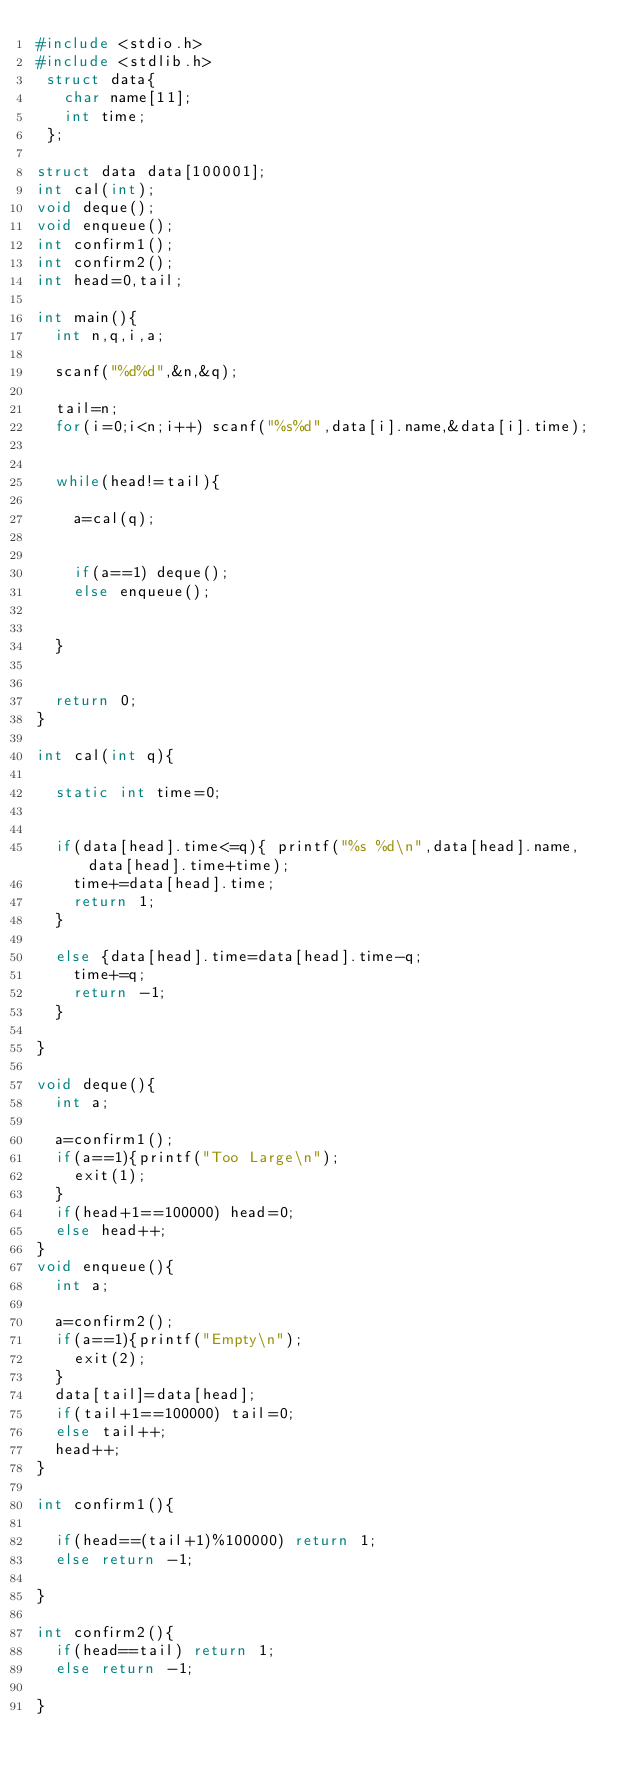Convert code to text. <code><loc_0><loc_0><loc_500><loc_500><_C_>#include <stdio.h>
#include <stdlib.h>
 struct data{
   char name[11];
   int time;
 };

struct data data[100001];
int cal(int);
void deque();
void enqueue();
int confirm1();
int confirm2();
int head=0,tail;
  
int main(){
  int n,q,i,a;
  
  scanf("%d%d",&n,&q);

  tail=n;
  for(i=0;i<n;i++) scanf("%s%d",data[i].name,&data[i].time);

   
  while(head!=tail){

    a=cal(q);
     
     
    if(a==1) deque();
    else enqueue();

     
  }


  return 0;
}

int cal(int q){

  static int time=0;
 
  
  if(data[head].time<=q){ printf("%s %d\n",data[head].name,data[head].time+time);
    time+=data[head].time;
    return 1;
  }

  else {data[head].time=data[head].time-q;
    time+=q;
    return -1;
  }

}

void deque(){
  int a;

  a=confirm1();
  if(a==1){printf("Too Large\n");
    exit(1);
  }
  if(head+1==100000) head=0;
  else head++;
}
void enqueue(){
  int a;

  a=confirm2();
  if(a==1){printf("Empty\n");
    exit(2);
  }
  data[tail]=data[head];
  if(tail+1==100000) tail=0;
  else tail++;
  head++;
}

int confirm1(){

  if(head==(tail+1)%100000) return 1;
  else return -1;
  
}

int confirm2(){
  if(head==tail) return 1;
  else return -1;

}</code> 